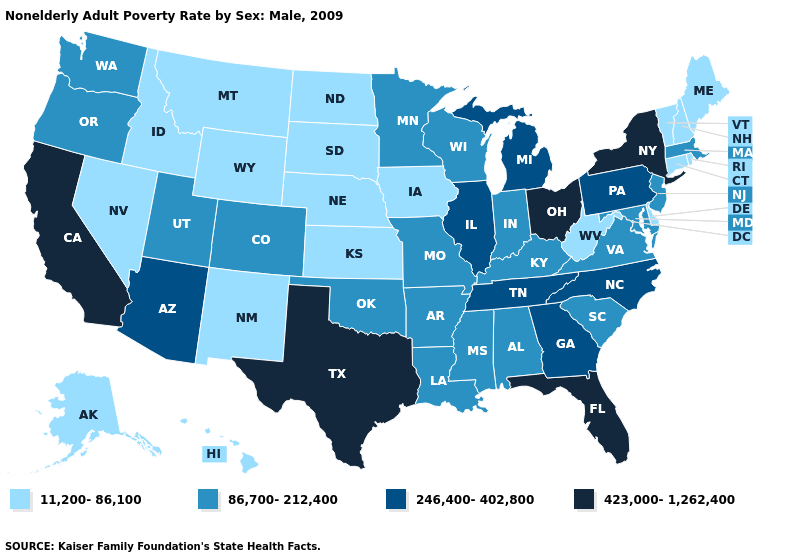Name the states that have a value in the range 86,700-212,400?
Give a very brief answer. Alabama, Arkansas, Colorado, Indiana, Kentucky, Louisiana, Maryland, Massachusetts, Minnesota, Mississippi, Missouri, New Jersey, Oklahoma, Oregon, South Carolina, Utah, Virginia, Washington, Wisconsin. Among the states that border Indiana , which have the lowest value?
Short answer required. Kentucky. What is the value of Mississippi?
Quick response, please. 86,700-212,400. Does Michigan have the same value as Wisconsin?
Write a very short answer. No. Among the states that border Tennessee , does Alabama have the highest value?
Answer briefly. No. Does Alabama have the same value as Kentucky?
Answer briefly. Yes. What is the value of Kentucky?
Give a very brief answer. 86,700-212,400. Does the first symbol in the legend represent the smallest category?
Quick response, please. Yes. Name the states that have a value in the range 86,700-212,400?
Concise answer only. Alabama, Arkansas, Colorado, Indiana, Kentucky, Louisiana, Maryland, Massachusetts, Minnesota, Mississippi, Missouri, New Jersey, Oklahoma, Oregon, South Carolina, Utah, Virginia, Washington, Wisconsin. What is the lowest value in the USA?
Quick response, please. 11,200-86,100. Which states have the highest value in the USA?
Short answer required. California, Florida, New York, Ohio, Texas. Which states have the lowest value in the West?
Answer briefly. Alaska, Hawaii, Idaho, Montana, Nevada, New Mexico, Wyoming. What is the value of South Carolina?
Write a very short answer. 86,700-212,400. Name the states that have a value in the range 86,700-212,400?
Keep it brief. Alabama, Arkansas, Colorado, Indiana, Kentucky, Louisiana, Maryland, Massachusetts, Minnesota, Mississippi, Missouri, New Jersey, Oklahoma, Oregon, South Carolina, Utah, Virginia, Washington, Wisconsin. What is the value of West Virginia?
Answer briefly. 11,200-86,100. 